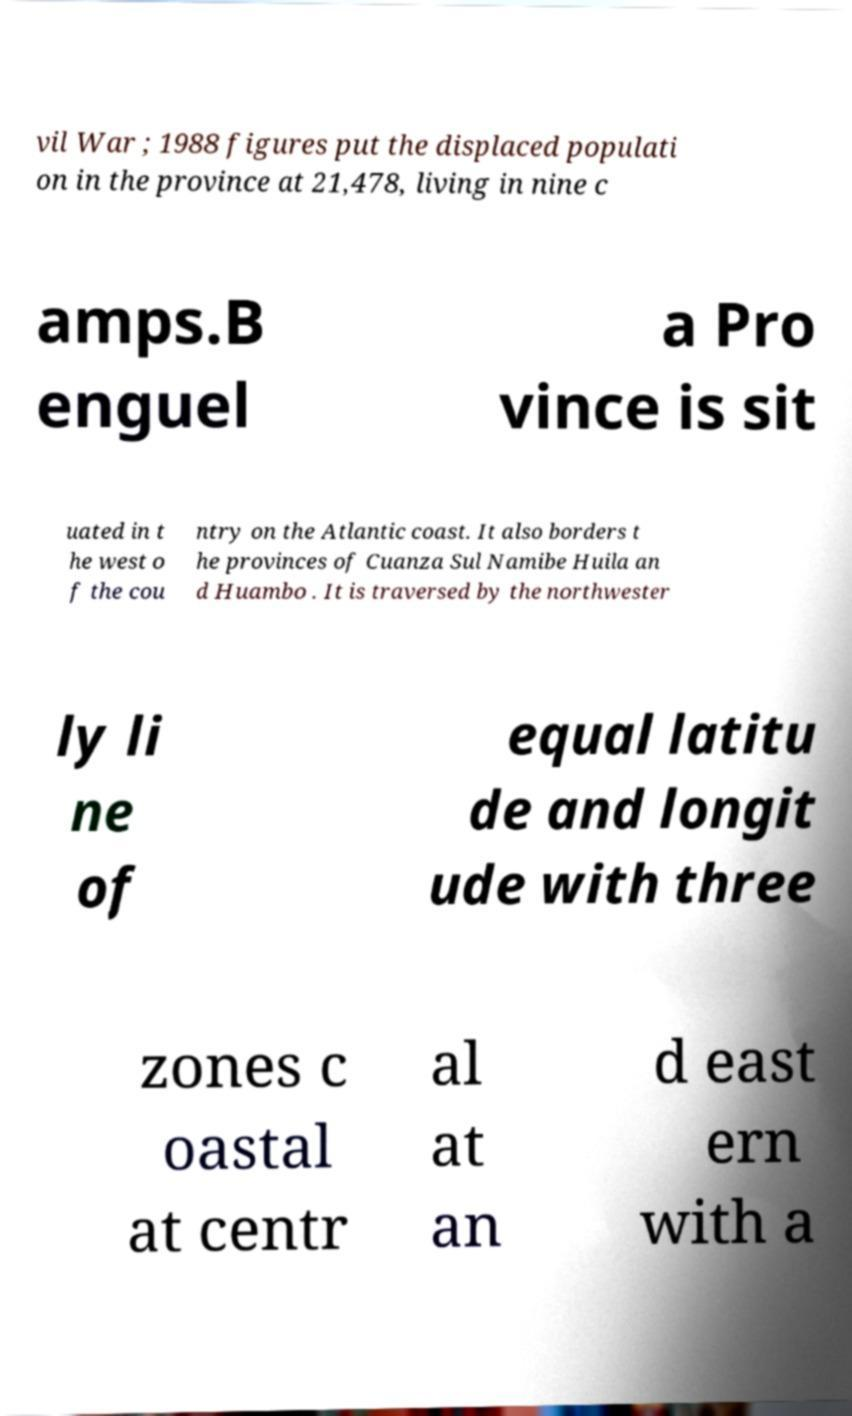Please read and relay the text visible in this image. What does it say? vil War ; 1988 figures put the displaced populati on in the province at 21,478, living in nine c amps.B enguel a Pro vince is sit uated in t he west o f the cou ntry on the Atlantic coast. It also borders t he provinces of Cuanza Sul Namibe Huila an d Huambo . It is traversed by the northwester ly li ne of equal latitu de and longit ude with three zones c oastal at centr al at an d east ern with a 